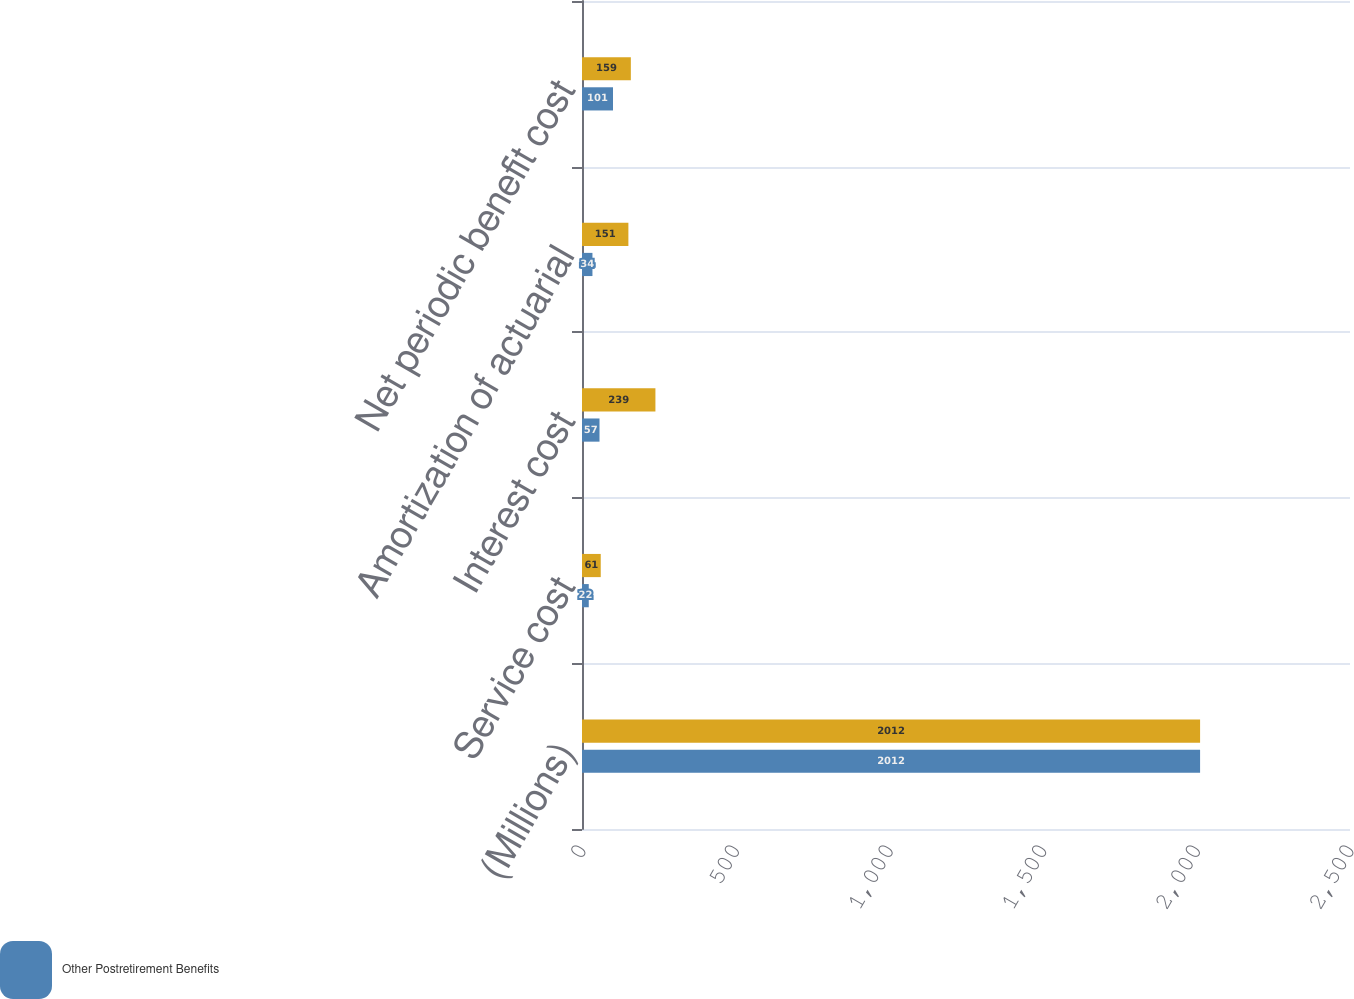Convert chart. <chart><loc_0><loc_0><loc_500><loc_500><stacked_bar_chart><ecel><fcel>(Millions)<fcel>Service cost<fcel>Interest cost<fcel>Amortization of actuarial<fcel>Net periodic benefit cost<nl><fcel>nan<fcel>2012<fcel>61<fcel>239<fcel>151<fcel>159<nl><fcel>Other Postretirement Benefits<fcel>2012<fcel>22<fcel>57<fcel>34<fcel>101<nl></chart> 